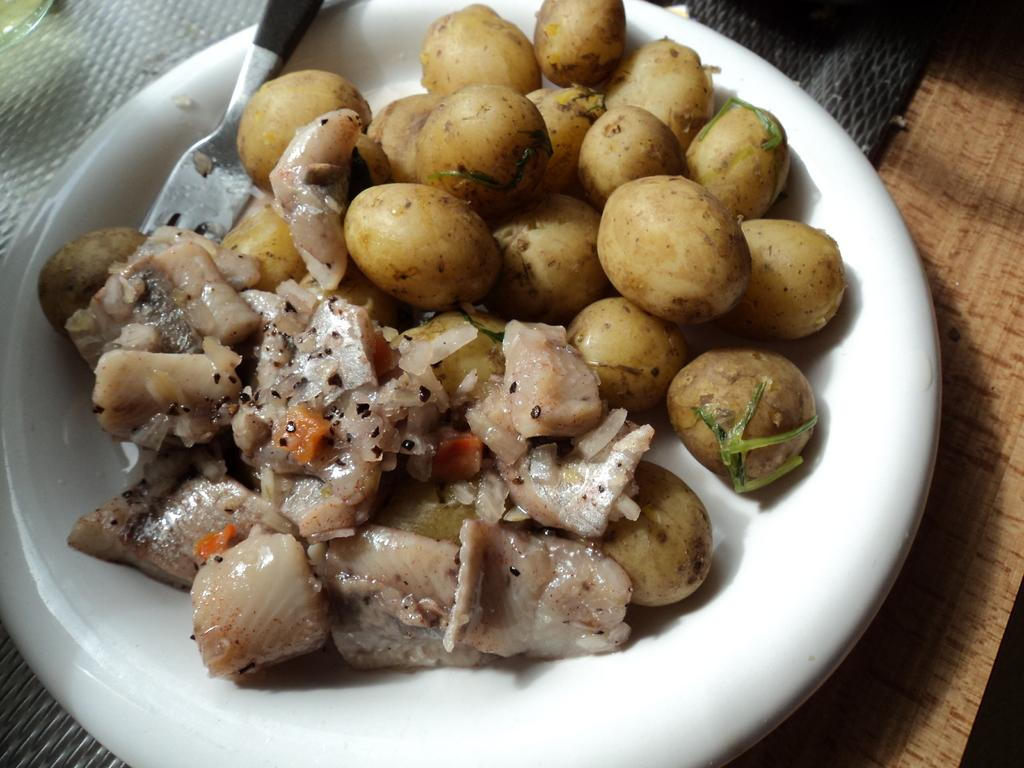What color is the plate in the image? The plate in the image is white. What is the plate placed on? The plate is on a wooden surface. What utensil can be seen in the plate? There is a fork in the plate. What type of food is present in the plate? Cooked potatoes are present in the plate. How many girls are standing next to the plate in the image? There are no girls present in the image; it only shows a plate with cooked potatoes and a fork. 